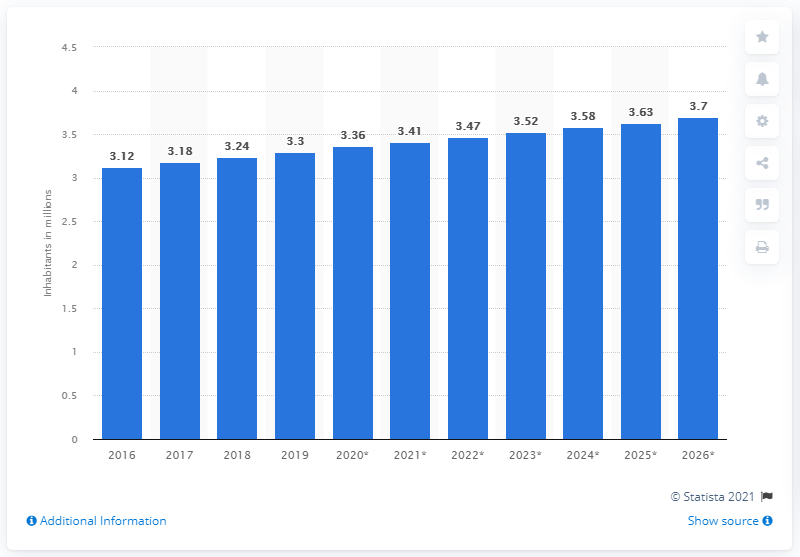Give some essential details in this illustration. In 2020, the population of Mongolia was approximately 3.36 million people. 